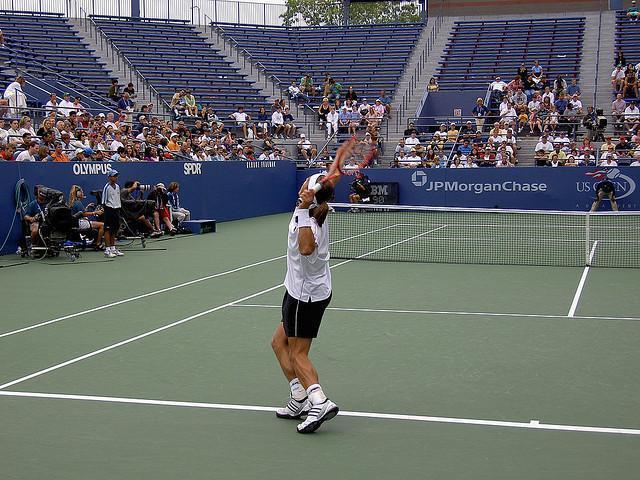How many stripes on the players shoe?
Give a very brief answer. 3. How many people can be seen?
Give a very brief answer. 2. 